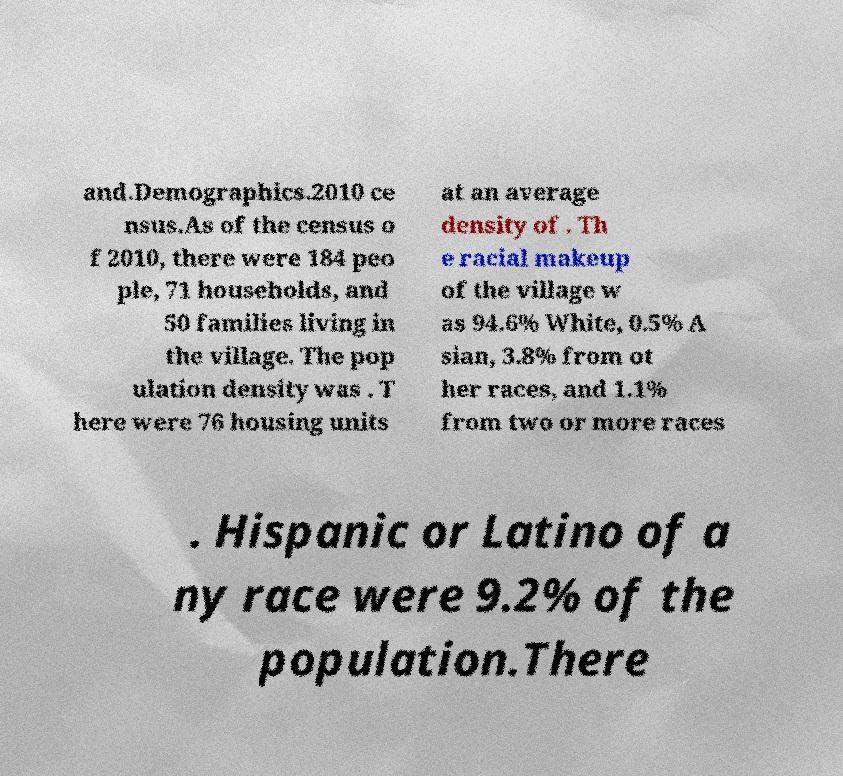What messages or text are displayed in this image? I need them in a readable, typed format. and.Demographics.2010 ce nsus.As of the census o f 2010, there were 184 peo ple, 71 households, and 50 families living in the village. The pop ulation density was . T here were 76 housing units at an average density of . Th e racial makeup of the village w as 94.6% White, 0.5% A sian, 3.8% from ot her races, and 1.1% from two or more races . Hispanic or Latino of a ny race were 9.2% of the population.There 